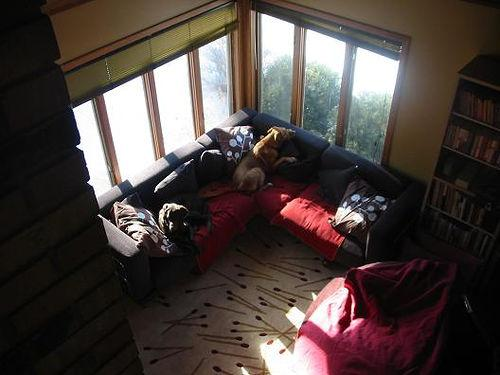What is on the couch?

Choices:
A) cow
B) dog
C) llama
D) old man dog 